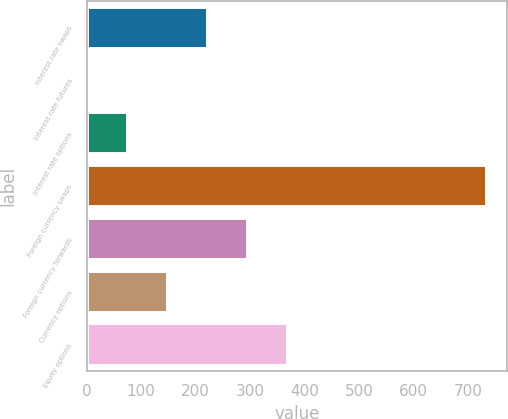Convert chart. <chart><loc_0><loc_0><loc_500><loc_500><bar_chart><fcel>Interest rate swaps<fcel>Interest rate futures<fcel>Interest rate options<fcel>Foreign currency swaps<fcel>Foreign currency forwards<fcel>Currency options<fcel>Equity options<nl><fcel>222.9<fcel>3<fcel>76.3<fcel>736<fcel>296.2<fcel>149.6<fcel>369.5<nl></chart> 